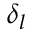<formula> <loc_0><loc_0><loc_500><loc_500>\delta _ { l }</formula> 